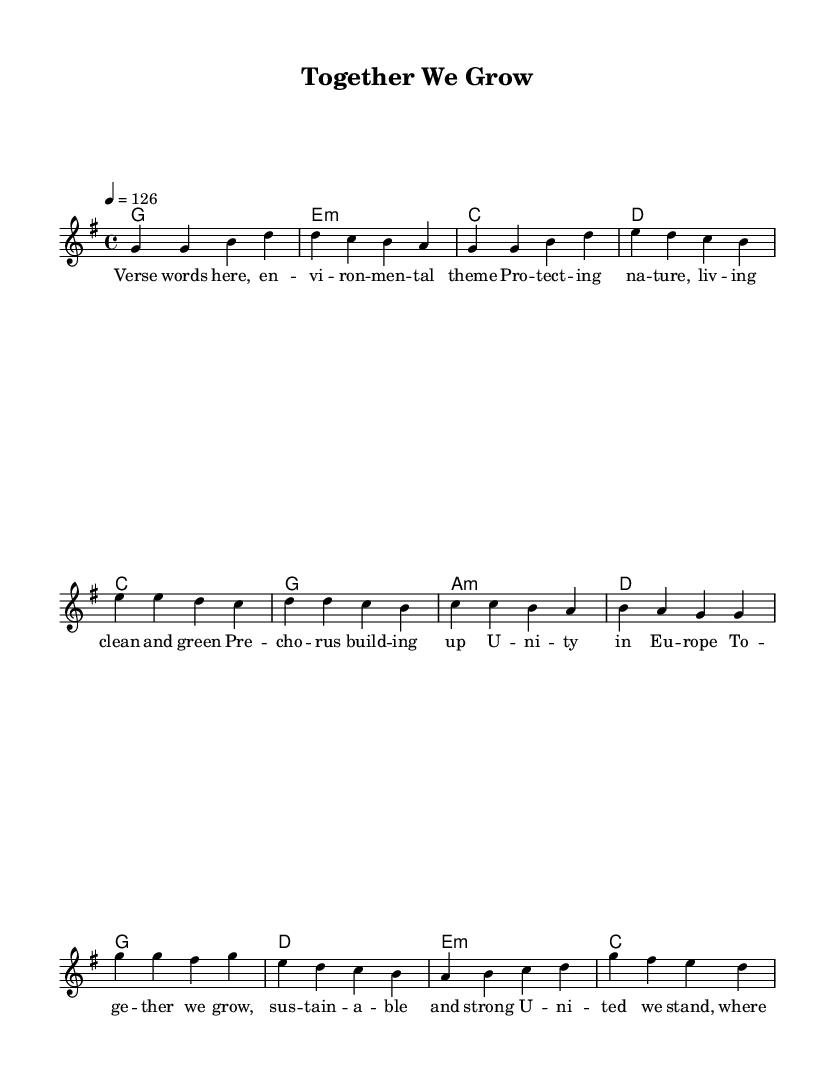What is the key signature of this music? The key signature is G major, which has one sharp (F#).
Answer: G major What is the time signature of the piece? The time signature is 4/4, indicating four beats per measure.
Answer: 4/4 What is the tempo marking of the song? The tempo marking is a quarter note equals 126 beats per minute, indicating a lively pace.
Answer: 126 How many measures are in the chorus? The chorus contains 4 measures, as indicated by the repetition of the melodic and harmonic structure.
Answer: 4 What is the first note of the melody in the verse? The first note of the melody in the verse is G, as shown at the beginning of the melody section.
Answer: G What is the primary theme conveyed in the lyrics? The primary theme conveyed is environmental protection and European unity, focused on sustainable living.
Answer: Environmental unity How many different chords are used in the verse section? There are 4 different chords (G, E minor, C, D) used in the verse section, indicated in the chord names.
Answer: 4 